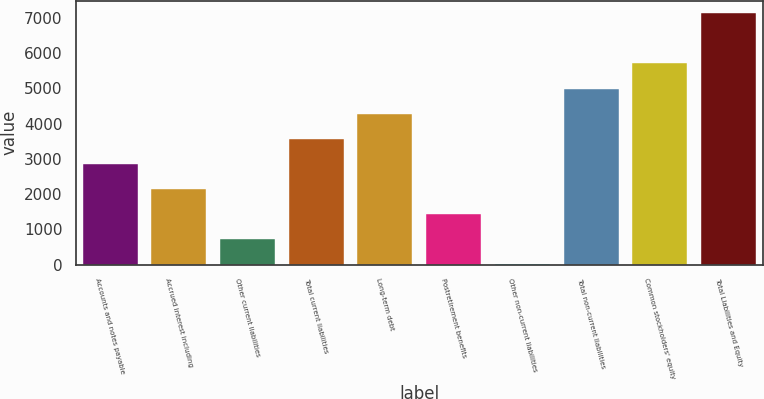Convert chart. <chart><loc_0><loc_0><loc_500><loc_500><bar_chart><fcel>Accounts and notes payable<fcel>Accrued interest including<fcel>Other current liabilities<fcel>Total current liabilities<fcel>Long-term debt<fcel>Postretirement benefits<fcel>Other non-current liabilities<fcel>Total non-current liabilities<fcel>Common stockholders' equity<fcel>Total Liabilities and Equity<nl><fcel>2855.4<fcel>2142.3<fcel>716.1<fcel>3568.5<fcel>4281.6<fcel>1429.2<fcel>3<fcel>4994.7<fcel>5707.8<fcel>7134<nl></chart> 